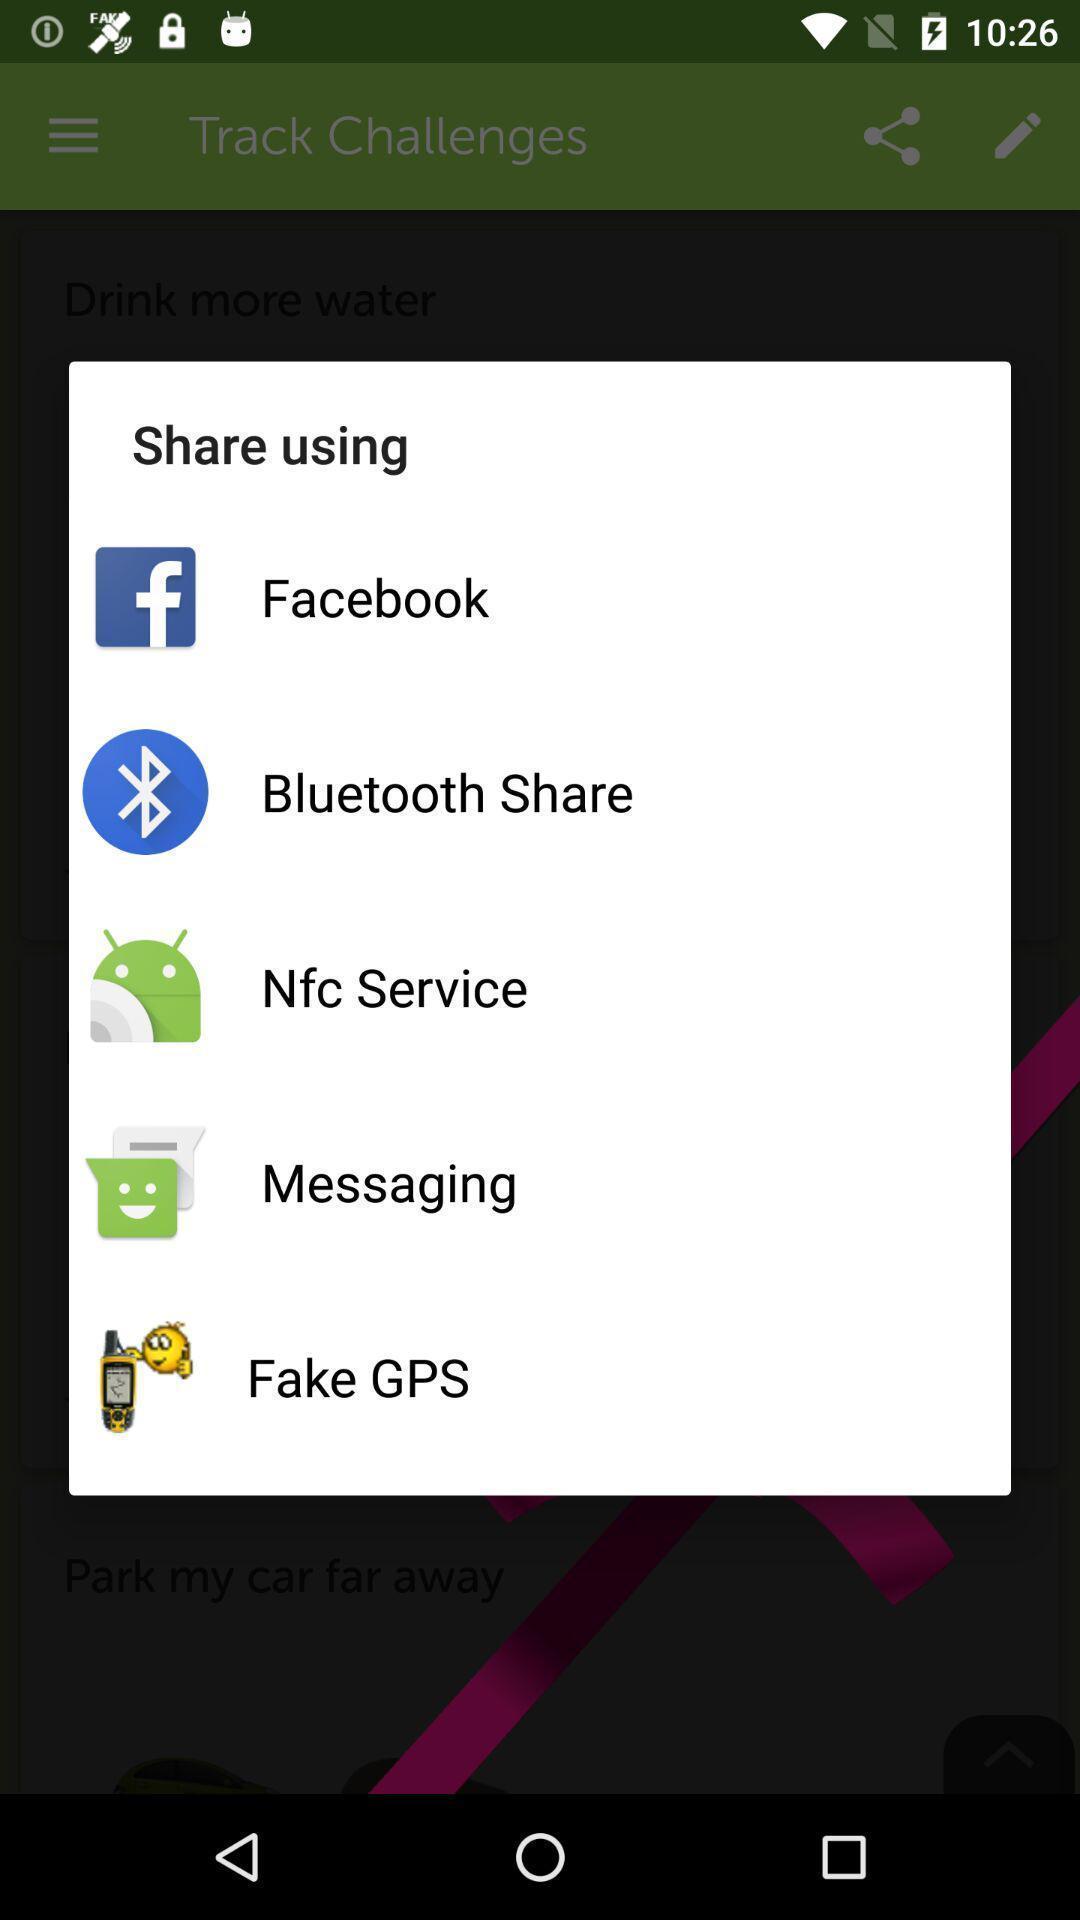What can you discern from this picture? Pop-up asking to share with different apps. 